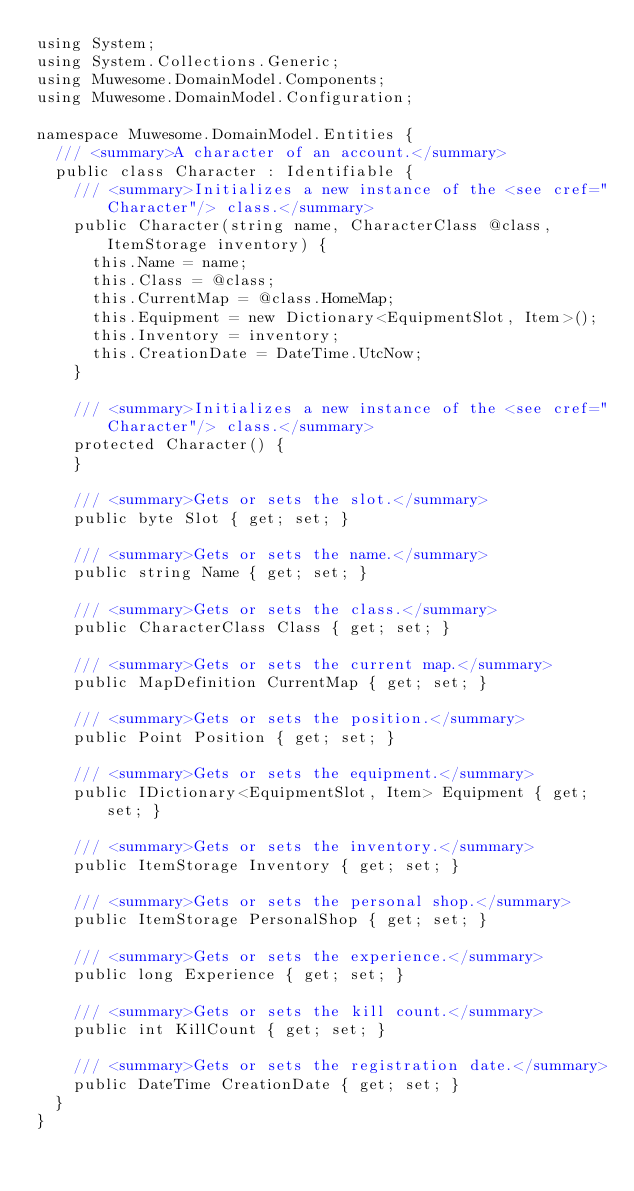<code> <loc_0><loc_0><loc_500><loc_500><_C#_>using System;
using System.Collections.Generic;
using Muwesome.DomainModel.Components;
using Muwesome.DomainModel.Configuration;

namespace Muwesome.DomainModel.Entities {
  /// <summary>A character of an account.</summary>
  public class Character : Identifiable {
    /// <summary>Initializes a new instance of the <see cref="Character"/> class.</summary>
    public Character(string name, CharacterClass @class, ItemStorage inventory) {
      this.Name = name;
      this.Class = @class;
      this.CurrentMap = @class.HomeMap;
      this.Equipment = new Dictionary<EquipmentSlot, Item>();
      this.Inventory = inventory;
      this.CreationDate = DateTime.UtcNow;
    }

    /// <summary>Initializes a new instance of the <see cref="Character"/> class.</summary>
    protected Character() {
    }

    /// <summary>Gets or sets the slot.</summary>
    public byte Slot { get; set; }

    /// <summary>Gets or sets the name.</summary>
    public string Name { get; set; }

    /// <summary>Gets or sets the class.</summary>
    public CharacterClass Class { get; set; }

    /// <summary>Gets or sets the current map.</summary>
    public MapDefinition CurrentMap { get; set; }

    /// <summary>Gets or sets the position.</summary>
    public Point Position { get; set; }

    /// <summary>Gets or sets the equipment.</summary>
    public IDictionary<EquipmentSlot, Item> Equipment { get; set; }

    /// <summary>Gets or sets the inventory.</summary>
    public ItemStorage Inventory { get; set; }

    /// <summary>Gets or sets the personal shop.</summary>
    public ItemStorage PersonalShop { get; set; }

    /// <summary>Gets or sets the experience.</summary>
    public long Experience { get; set; }

    /// <summary>Gets or sets the kill count.</summary>
    public int KillCount { get; set; }

    /// <summary>Gets or sets the registration date.</summary>
    public DateTime CreationDate { get; set; }
  }
}</code> 